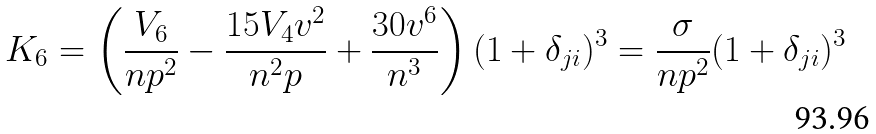<formula> <loc_0><loc_0><loc_500><loc_500>K _ { 6 } = \left ( \frac { V _ { 6 } } { n p ^ { 2 } } - \frac { 1 5 V _ { 4 } v ^ { 2 } } { n ^ { 2 } p } + \frac { 3 0 v ^ { 6 } } { n ^ { 3 } } \right ) ( 1 + \delta _ { j i } ) ^ { 3 } = \frac { \sigma } { n p ^ { 2 } } ( 1 + \delta _ { j i } ) ^ { 3 }</formula> 